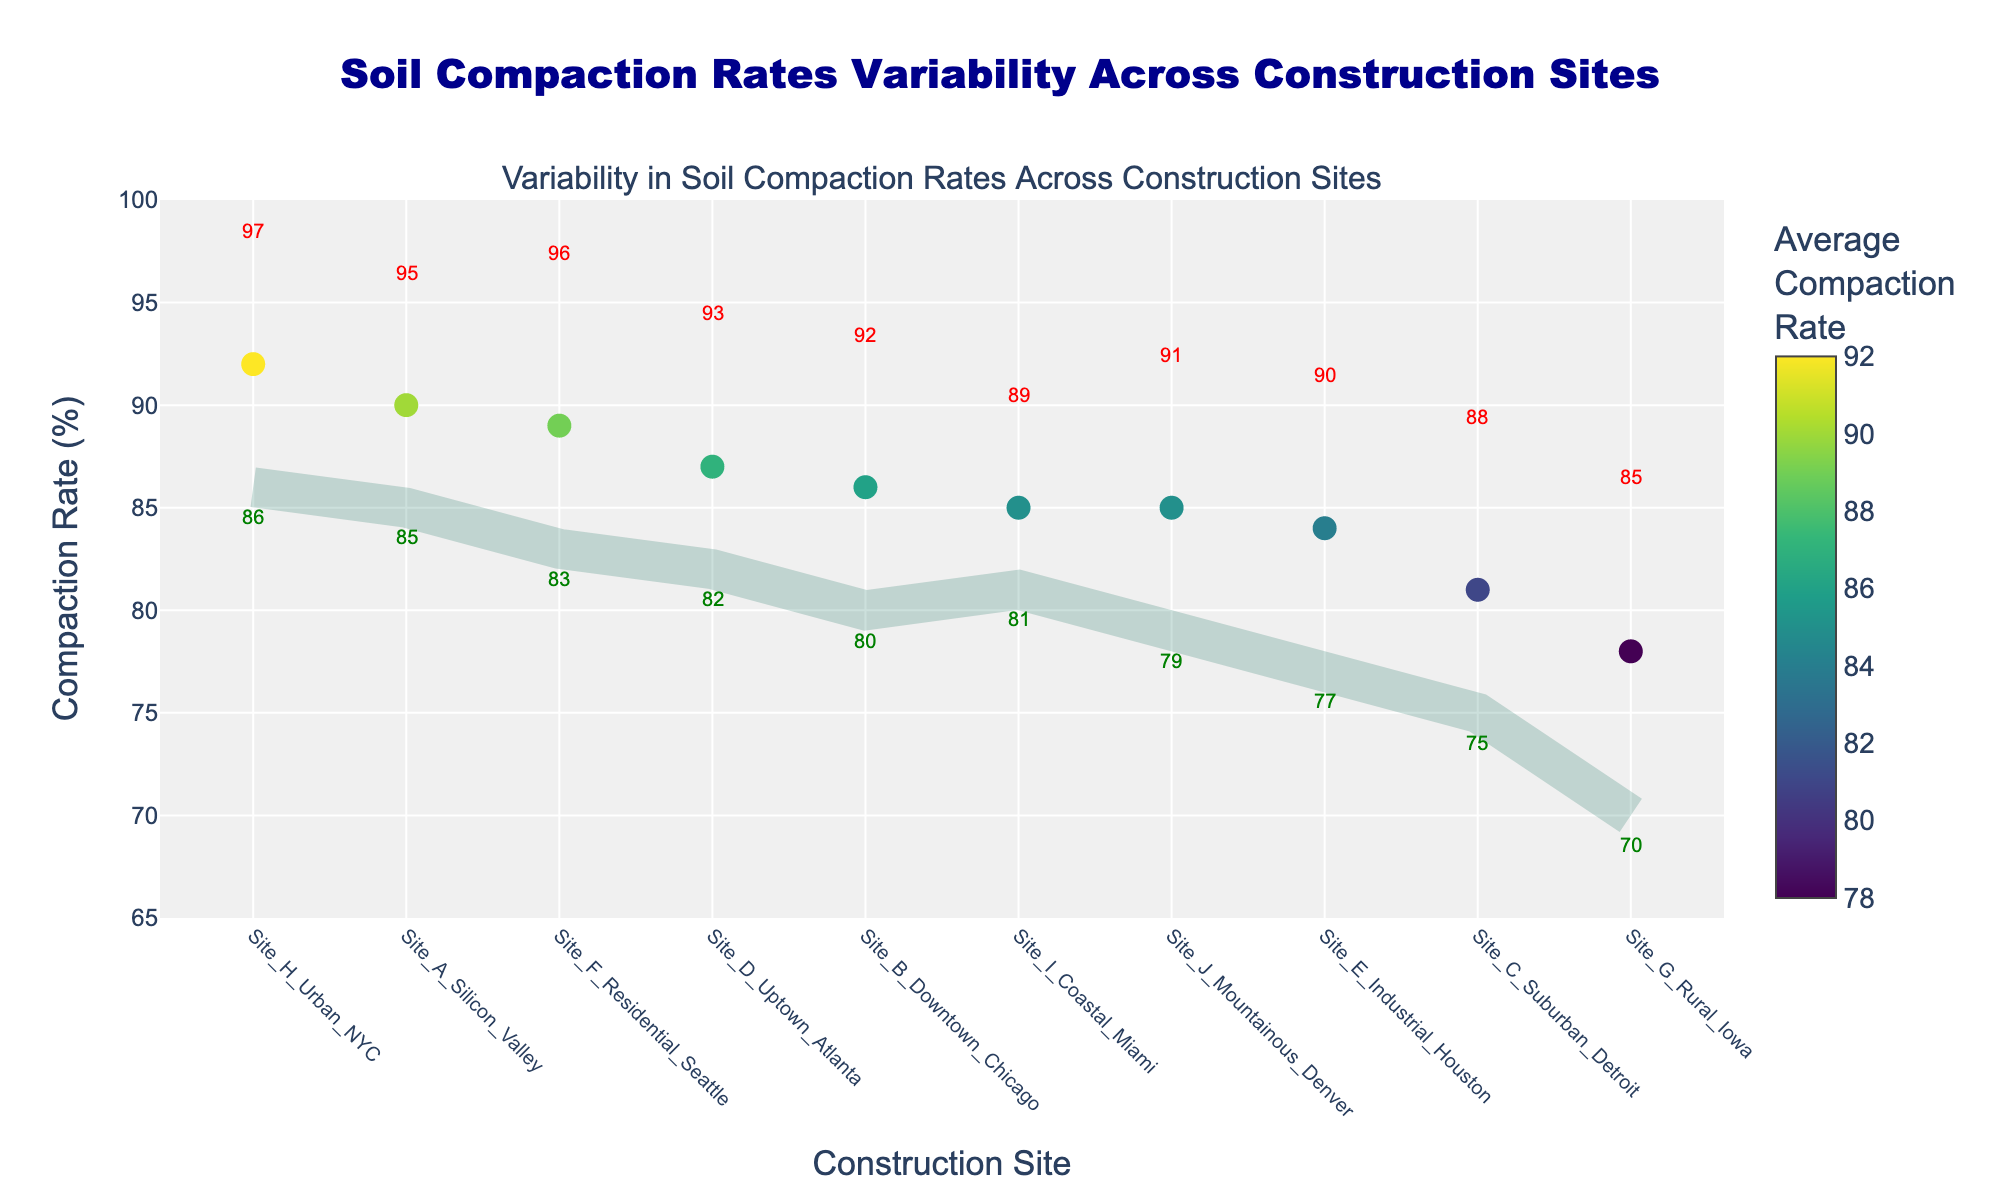What is the title of the figure? The title of the figure is usually placed at the top center and it reads "Soil Compaction Rates Variability Across Construction Sites".
Answer: Soil Compaction Rates Variability Across Construction Sites What is the range of compaction rates for Site_H_Urban_NYC? Look at the horizontal line for Site_H_Urban_NYC. The endpoints indicate the min and max values which are annotated as 86 and 97, respectively.
Answer: 86-97 Which construction site has the highest average compaction rate? Identify the construction site with the highest dot position on the y-axis. The label shows Site_H_Urban_NYC with an average compaction rate of 92.
Answer: Site_H_Urban_NYC Which site shows the greatest variability in compaction rates? Find the site with the longest horizontal line indicating the difference between the max and min compaction rates. Site_G_Rural_Iowa has the largest range from 70 to 85.
Answer: Site_G_Rural_Iowa What is the compaction rate for the midpoint of Site_I_Coastal_Miami’s range? Average the min and max compaction rates for Site_I_Coastal_Miami: (81 + 89) / 2 = 85.
Answer: 85 Which construction site has a minimum compaction rate greater than 80%? Review each site to find those with a min compaction rate above 80. These include Site_A_Silicon_Valley, Site_B_Downtown_Chicago, Site_D_Uptown_Atlanta, Site_F_Residential_Seattle, Site_H_Urban_NYC, and Site_I_Coastal_Miami.
Answer: Site_A_Silicon_Valley, Site_B_Downtown_Chicago, Site_D_Uptown_Atlanta, Site_F_Residential_Seattle, Site_H_Urban_NYC, Site_I_Coastal_Miami What is the average compaction rate for Site_D_Uptown_Atlanta? Locate the dot for Site_D_Uptown_Atlanta, indicated as 87.
Answer: 87 Between Site_B_Downtown_Chicago and Site_F_Residential_Seattle, which has a higher maximum compaction rate? Compare the max annotations for both sites. Site_F_Residential_Seattle has a higher value of 96 compared to Site_B_Downtown_Chicago’s 92.
Answer: Site_F_Residential_Seattle What is the difference between the max and min compaction rates for Site_C_Suburban_Detroit? Subtract the min value from the max value for Site_C_Suburban_Detroit: 88 - 75 = 13.
Answer: 13 How many construction sites have an average compaction rate of 85 or higher? Count the construction sites with an average compaction rate of 85 or above, which are: Site_A_Silicon_Valley, Site_B_Downtown_Chicago, Site_D_Uptown_Atlanta, Site_F_Residential_Seattle, Site_H_Urban_NYC, Site_I_Coastal_Miami, and Site_J_Mountainous_Denver. There are 7 such sites.
Answer: 7 